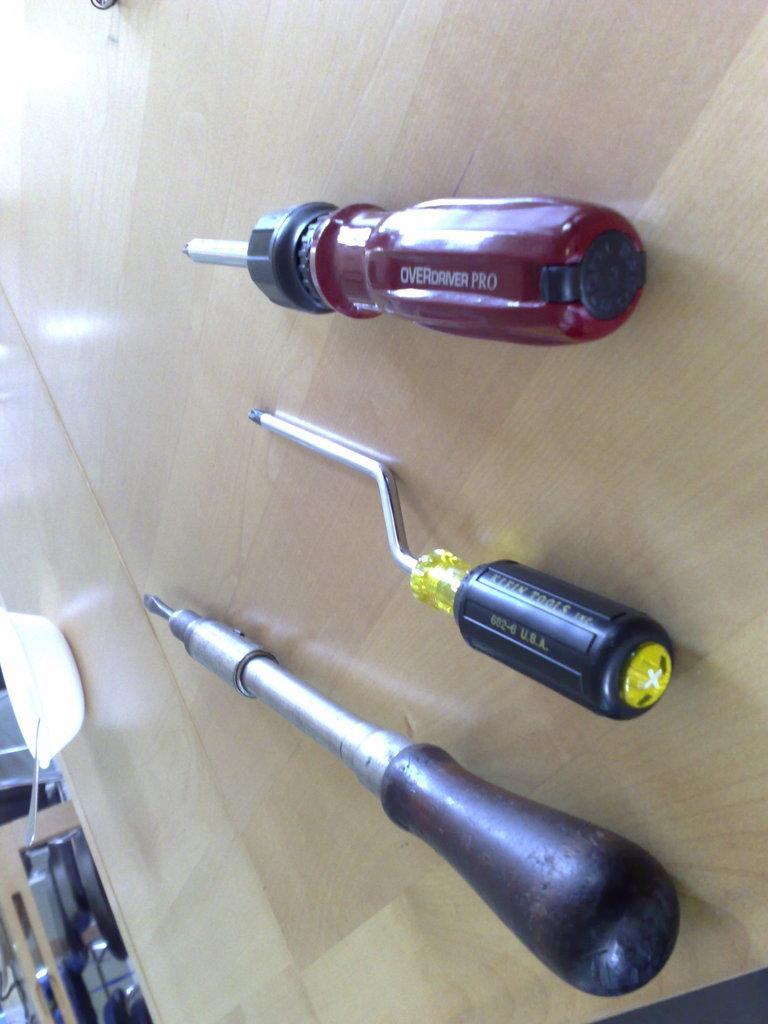Please provide a concise description of this image. In this picture, we can see table and some objects on the table like equipments, a bowl with spoon, and we can see some objects in the bottom left side of the picture. 